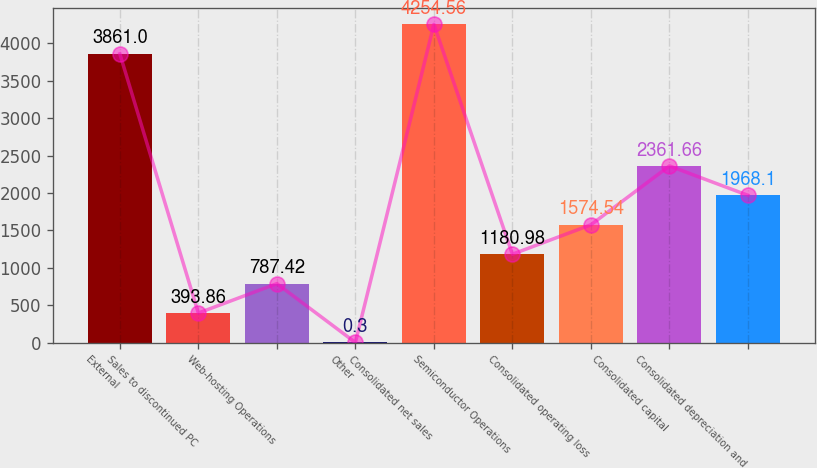Convert chart. <chart><loc_0><loc_0><loc_500><loc_500><bar_chart><fcel>External<fcel>Sales to discontinued PC<fcel>Web-hosting Operations<fcel>Other<fcel>Consolidated net sales<fcel>Semiconductor Operations<fcel>Consolidated operating loss<fcel>Consolidated capital<fcel>Consolidated depreciation and<nl><fcel>3861<fcel>393.86<fcel>787.42<fcel>0.3<fcel>4254.56<fcel>1180.98<fcel>1574.54<fcel>2361.66<fcel>1968.1<nl></chart> 